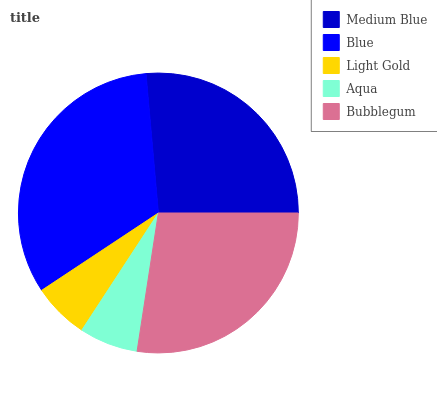Is Light Gold the minimum?
Answer yes or no. Yes. Is Blue the maximum?
Answer yes or no. Yes. Is Blue the minimum?
Answer yes or no. No. Is Light Gold the maximum?
Answer yes or no. No. Is Blue greater than Light Gold?
Answer yes or no. Yes. Is Light Gold less than Blue?
Answer yes or no. Yes. Is Light Gold greater than Blue?
Answer yes or no. No. Is Blue less than Light Gold?
Answer yes or no. No. Is Medium Blue the high median?
Answer yes or no. Yes. Is Medium Blue the low median?
Answer yes or no. Yes. Is Blue the high median?
Answer yes or no. No. Is Aqua the low median?
Answer yes or no. No. 